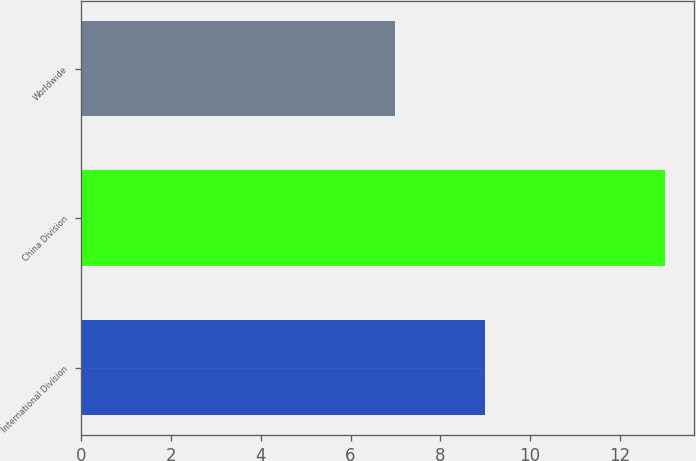Convert chart. <chart><loc_0><loc_0><loc_500><loc_500><bar_chart><fcel>International Division<fcel>China Division<fcel>Worldwide<nl><fcel>9<fcel>13<fcel>7<nl></chart> 